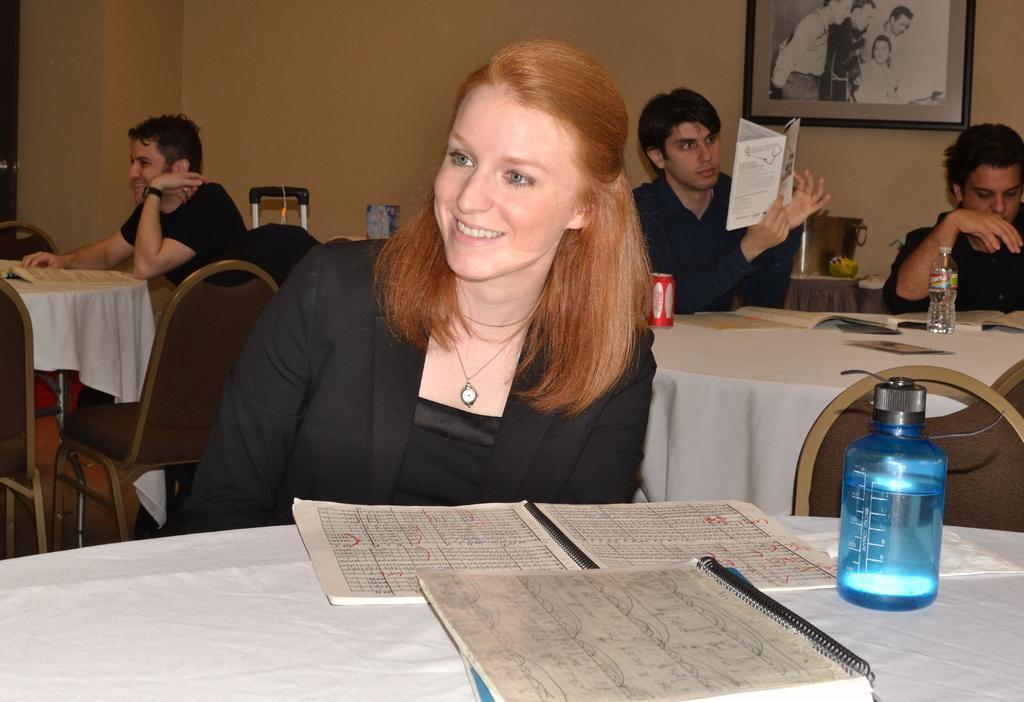How would you summarize this image in a sentence or two? These persons are sitting on a chair. A picture on wall. In-front of these persons there is a table, on this table there is a cloth, books, tin and bottle. Far there is a luggage. This man is holding a book. This woman wore black suit and holds a smile. 